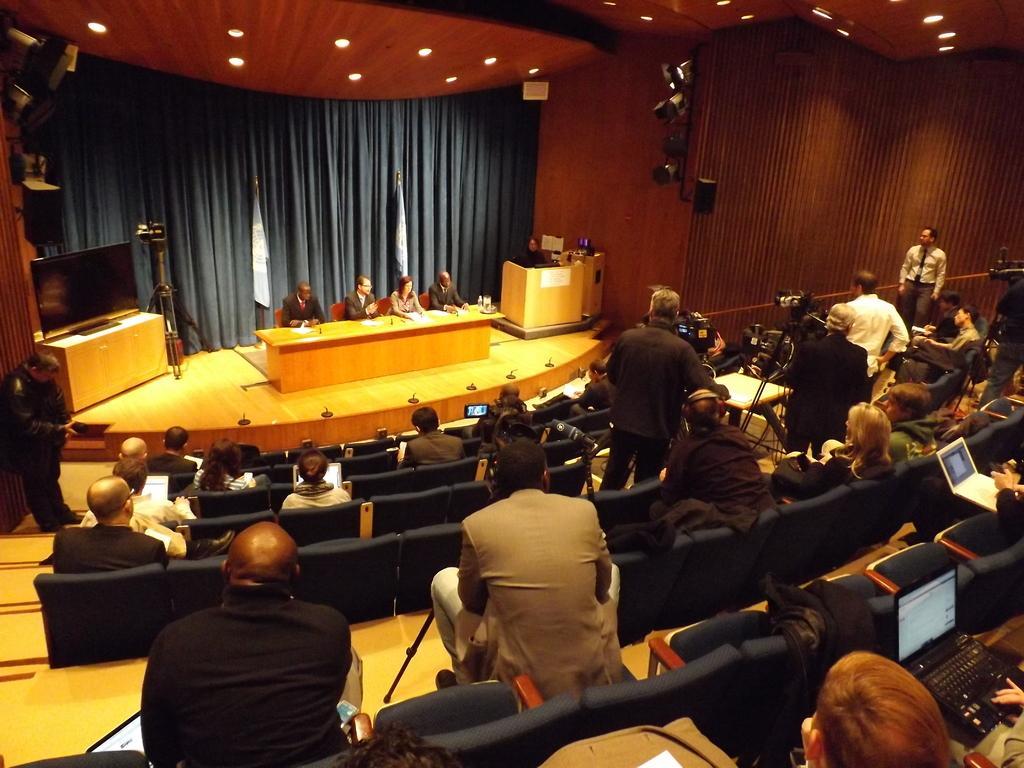Can you describe this image briefly? In the picture it is an auditorium, on the stage few people were sitting in front of the table and around them there is a television, lights and other equipment. In front of the stage many people are sitting on the chairs and some of them are working with laptops, in between the people there are few photographers. In the background there is a curtain. 